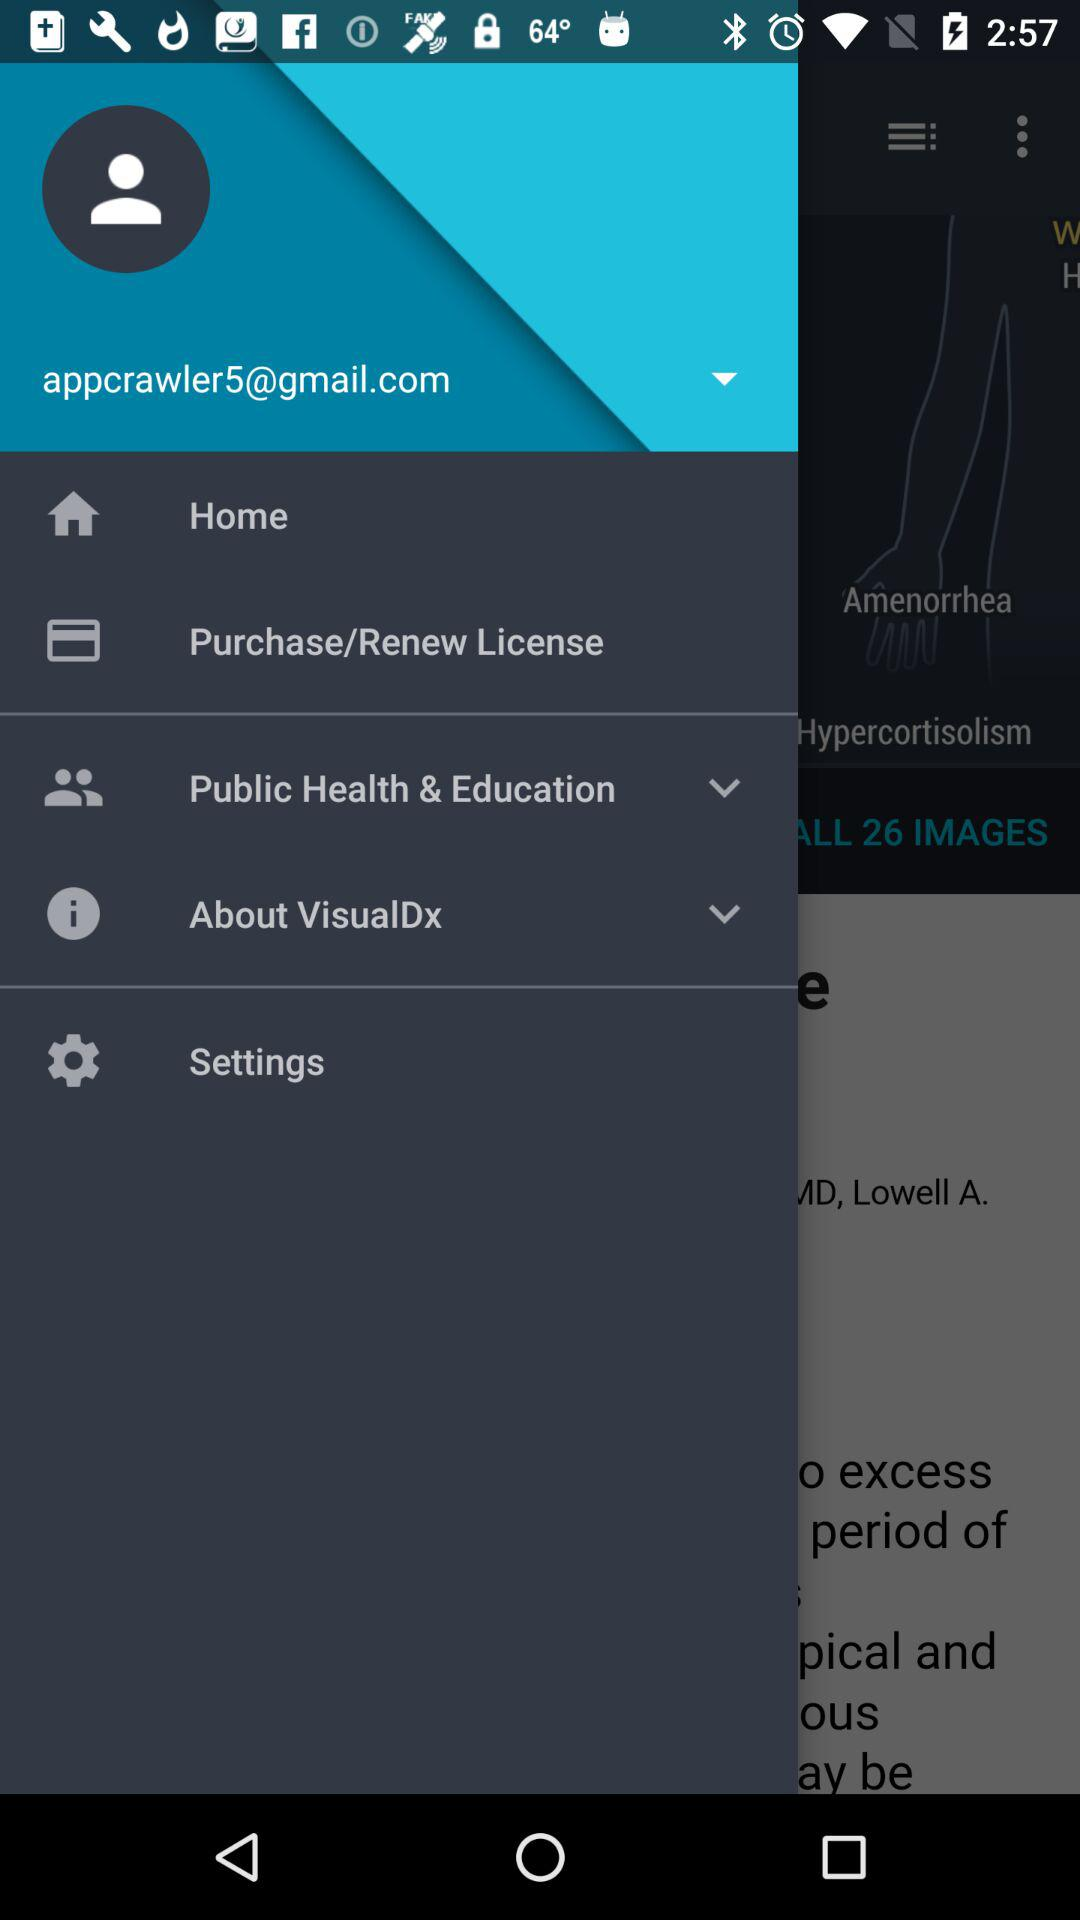When was the license purchased or renewed?
When the provided information is insufficient, respond with <no answer>. <no answer> 